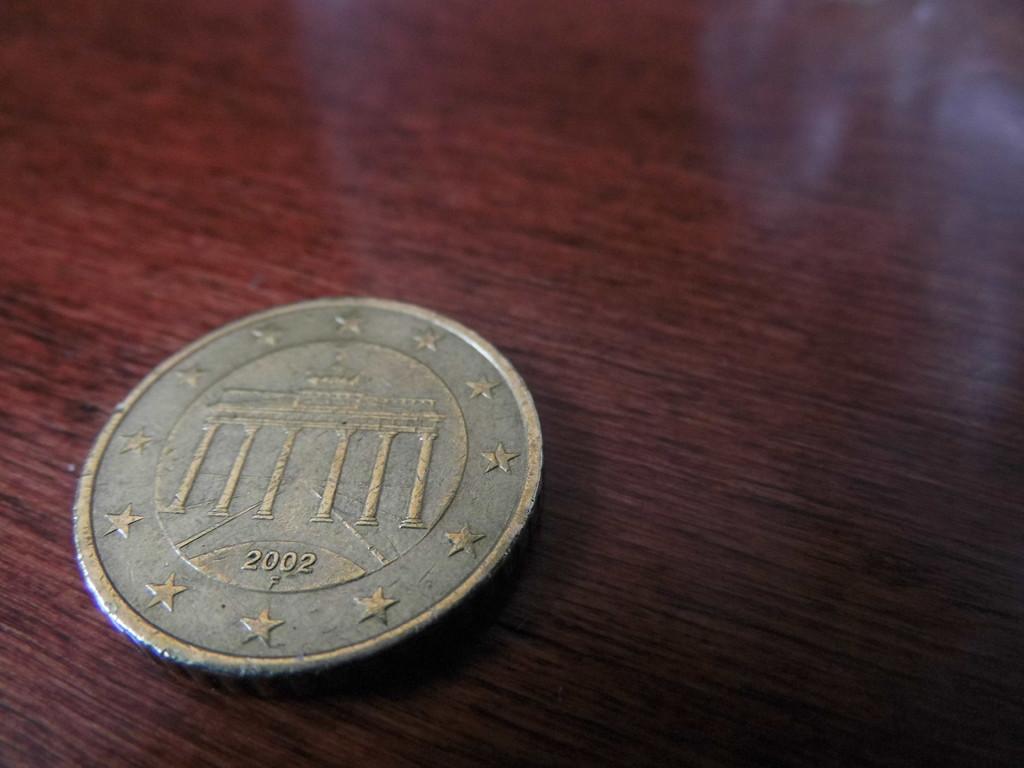What year was the coin minted in?
Provide a short and direct response. 2002. 